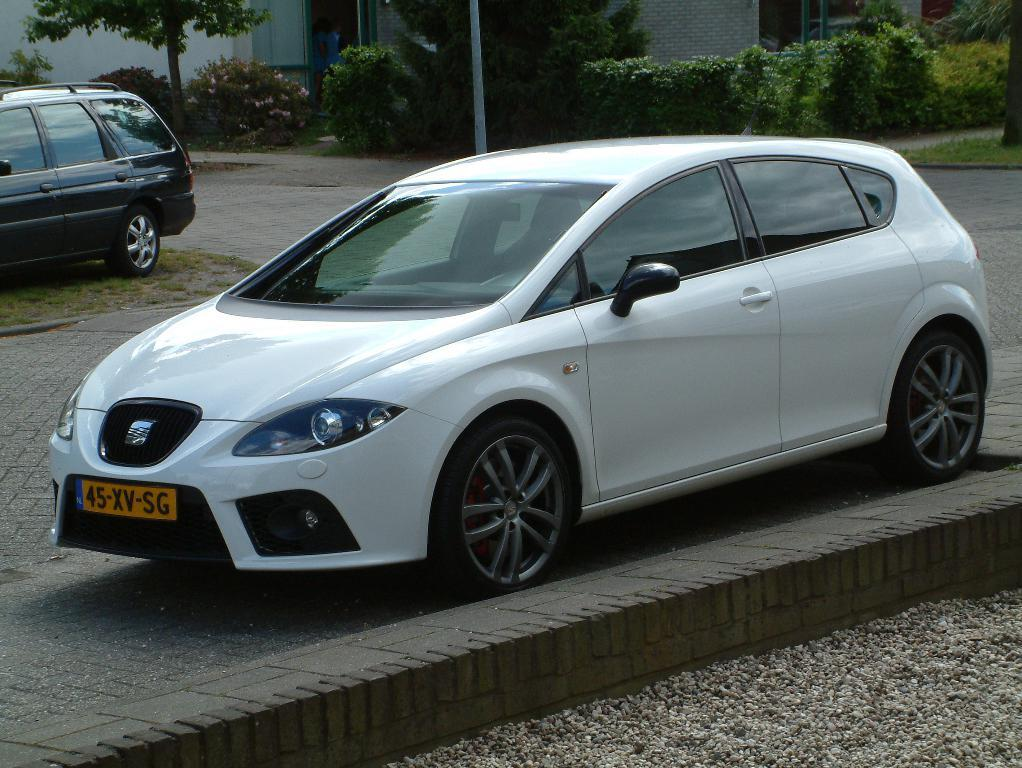What is the main subject in the center of the image? There is a car in the center of the image. Where is the car located? The car is on the road. What else can be seen on the left side of the image? There is another car and a tree on the left side of the image. What can be seen in the background of the image? There is a building, trees, plants, and a pole in the background of the image. What type of nut is being used as a gate in the image? There is no nut or gate present in the image. What activity are the people in the image participating in? There are no people visible in the image, so it is not possible to determine what activity they might be participating in. 